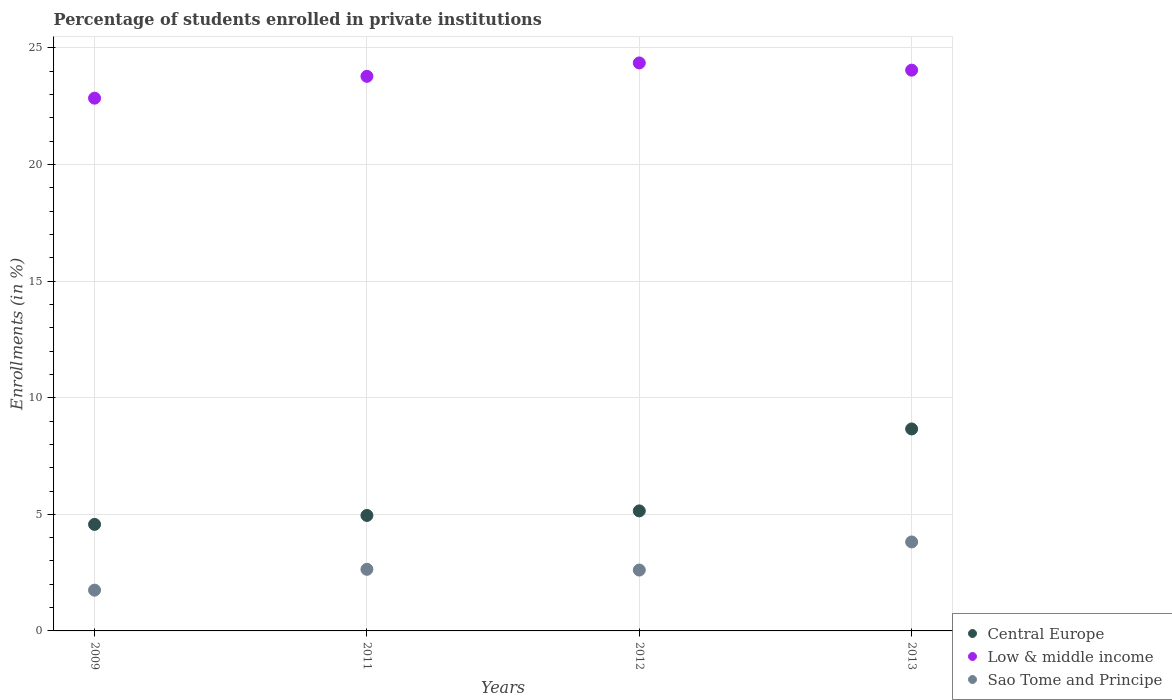How many different coloured dotlines are there?
Offer a terse response. 3. Is the number of dotlines equal to the number of legend labels?
Ensure brevity in your answer.  Yes. What is the percentage of trained teachers in Low & middle income in 2013?
Provide a short and direct response. 24.05. Across all years, what is the maximum percentage of trained teachers in Sao Tome and Principe?
Provide a succinct answer. 3.82. Across all years, what is the minimum percentage of trained teachers in Low & middle income?
Your answer should be compact. 22.85. In which year was the percentage of trained teachers in Central Europe maximum?
Offer a very short reply. 2013. What is the total percentage of trained teachers in Sao Tome and Principe in the graph?
Offer a terse response. 10.82. What is the difference between the percentage of trained teachers in Low & middle income in 2011 and that in 2013?
Provide a short and direct response. -0.26. What is the difference between the percentage of trained teachers in Central Europe in 2013 and the percentage of trained teachers in Low & middle income in 2012?
Provide a short and direct response. -15.7. What is the average percentage of trained teachers in Central Europe per year?
Offer a very short reply. 5.83. In the year 2009, what is the difference between the percentage of trained teachers in Sao Tome and Principe and percentage of trained teachers in Central Europe?
Offer a very short reply. -2.82. What is the ratio of the percentage of trained teachers in Low & middle income in 2011 to that in 2013?
Your answer should be compact. 0.99. What is the difference between the highest and the second highest percentage of trained teachers in Low & middle income?
Provide a short and direct response. 0.31. What is the difference between the highest and the lowest percentage of trained teachers in Sao Tome and Principe?
Keep it short and to the point. 2.07. In how many years, is the percentage of trained teachers in Central Europe greater than the average percentage of trained teachers in Central Europe taken over all years?
Offer a terse response. 1. Is the sum of the percentage of trained teachers in Low & middle income in 2011 and 2013 greater than the maximum percentage of trained teachers in Sao Tome and Principe across all years?
Offer a terse response. Yes. Does the percentage of trained teachers in Sao Tome and Principe monotonically increase over the years?
Your answer should be very brief. No. Is the percentage of trained teachers in Sao Tome and Principe strictly less than the percentage of trained teachers in Low & middle income over the years?
Give a very brief answer. Yes. How many dotlines are there?
Your answer should be very brief. 3. How many years are there in the graph?
Make the answer very short. 4. What is the difference between two consecutive major ticks on the Y-axis?
Your answer should be compact. 5. Are the values on the major ticks of Y-axis written in scientific E-notation?
Your answer should be compact. No. Does the graph contain any zero values?
Make the answer very short. No. How many legend labels are there?
Provide a succinct answer. 3. What is the title of the graph?
Offer a very short reply. Percentage of students enrolled in private institutions. What is the label or title of the Y-axis?
Give a very brief answer. Enrollments (in %). What is the Enrollments (in %) in Central Europe in 2009?
Offer a very short reply. 4.57. What is the Enrollments (in %) of Low & middle income in 2009?
Keep it short and to the point. 22.85. What is the Enrollments (in %) in Sao Tome and Principe in 2009?
Give a very brief answer. 1.75. What is the Enrollments (in %) of Central Europe in 2011?
Keep it short and to the point. 4.95. What is the Enrollments (in %) in Low & middle income in 2011?
Provide a succinct answer. 23.78. What is the Enrollments (in %) in Sao Tome and Principe in 2011?
Provide a short and direct response. 2.64. What is the Enrollments (in %) in Central Europe in 2012?
Offer a terse response. 5.15. What is the Enrollments (in %) of Low & middle income in 2012?
Provide a succinct answer. 24.36. What is the Enrollments (in %) in Sao Tome and Principe in 2012?
Give a very brief answer. 2.61. What is the Enrollments (in %) of Central Europe in 2013?
Make the answer very short. 8.66. What is the Enrollments (in %) in Low & middle income in 2013?
Your response must be concise. 24.05. What is the Enrollments (in %) of Sao Tome and Principe in 2013?
Provide a short and direct response. 3.82. Across all years, what is the maximum Enrollments (in %) of Central Europe?
Make the answer very short. 8.66. Across all years, what is the maximum Enrollments (in %) in Low & middle income?
Give a very brief answer. 24.36. Across all years, what is the maximum Enrollments (in %) of Sao Tome and Principe?
Your answer should be compact. 3.82. Across all years, what is the minimum Enrollments (in %) of Central Europe?
Provide a succinct answer. 4.57. Across all years, what is the minimum Enrollments (in %) of Low & middle income?
Keep it short and to the point. 22.85. Across all years, what is the minimum Enrollments (in %) of Sao Tome and Principe?
Offer a very short reply. 1.75. What is the total Enrollments (in %) in Central Europe in the graph?
Keep it short and to the point. 23.33. What is the total Enrollments (in %) in Low & middle income in the graph?
Your response must be concise. 95.03. What is the total Enrollments (in %) of Sao Tome and Principe in the graph?
Offer a terse response. 10.82. What is the difference between the Enrollments (in %) in Central Europe in 2009 and that in 2011?
Your response must be concise. -0.38. What is the difference between the Enrollments (in %) in Low & middle income in 2009 and that in 2011?
Your response must be concise. -0.94. What is the difference between the Enrollments (in %) in Sao Tome and Principe in 2009 and that in 2011?
Keep it short and to the point. -0.89. What is the difference between the Enrollments (in %) in Central Europe in 2009 and that in 2012?
Ensure brevity in your answer.  -0.58. What is the difference between the Enrollments (in %) of Low & middle income in 2009 and that in 2012?
Offer a very short reply. -1.51. What is the difference between the Enrollments (in %) in Sao Tome and Principe in 2009 and that in 2012?
Offer a very short reply. -0.86. What is the difference between the Enrollments (in %) of Central Europe in 2009 and that in 2013?
Keep it short and to the point. -4.09. What is the difference between the Enrollments (in %) in Low & middle income in 2009 and that in 2013?
Your response must be concise. -1.2. What is the difference between the Enrollments (in %) of Sao Tome and Principe in 2009 and that in 2013?
Make the answer very short. -2.07. What is the difference between the Enrollments (in %) in Central Europe in 2011 and that in 2012?
Give a very brief answer. -0.2. What is the difference between the Enrollments (in %) of Low & middle income in 2011 and that in 2012?
Give a very brief answer. -0.57. What is the difference between the Enrollments (in %) in Sao Tome and Principe in 2011 and that in 2012?
Keep it short and to the point. 0.03. What is the difference between the Enrollments (in %) of Central Europe in 2011 and that in 2013?
Offer a very short reply. -3.71. What is the difference between the Enrollments (in %) of Low & middle income in 2011 and that in 2013?
Your answer should be compact. -0.26. What is the difference between the Enrollments (in %) in Sao Tome and Principe in 2011 and that in 2013?
Provide a succinct answer. -1.17. What is the difference between the Enrollments (in %) of Central Europe in 2012 and that in 2013?
Your answer should be very brief. -3.51. What is the difference between the Enrollments (in %) in Low & middle income in 2012 and that in 2013?
Provide a succinct answer. 0.31. What is the difference between the Enrollments (in %) of Sao Tome and Principe in 2012 and that in 2013?
Offer a terse response. -1.21. What is the difference between the Enrollments (in %) of Central Europe in 2009 and the Enrollments (in %) of Low & middle income in 2011?
Provide a succinct answer. -19.21. What is the difference between the Enrollments (in %) of Central Europe in 2009 and the Enrollments (in %) of Sao Tome and Principe in 2011?
Your response must be concise. 1.93. What is the difference between the Enrollments (in %) in Low & middle income in 2009 and the Enrollments (in %) in Sao Tome and Principe in 2011?
Your answer should be compact. 20.2. What is the difference between the Enrollments (in %) of Central Europe in 2009 and the Enrollments (in %) of Low & middle income in 2012?
Give a very brief answer. -19.79. What is the difference between the Enrollments (in %) of Central Europe in 2009 and the Enrollments (in %) of Sao Tome and Principe in 2012?
Offer a very short reply. 1.96. What is the difference between the Enrollments (in %) of Low & middle income in 2009 and the Enrollments (in %) of Sao Tome and Principe in 2012?
Your response must be concise. 20.24. What is the difference between the Enrollments (in %) of Central Europe in 2009 and the Enrollments (in %) of Low & middle income in 2013?
Your response must be concise. -19.48. What is the difference between the Enrollments (in %) of Central Europe in 2009 and the Enrollments (in %) of Sao Tome and Principe in 2013?
Ensure brevity in your answer.  0.75. What is the difference between the Enrollments (in %) in Low & middle income in 2009 and the Enrollments (in %) in Sao Tome and Principe in 2013?
Offer a terse response. 19.03. What is the difference between the Enrollments (in %) of Central Europe in 2011 and the Enrollments (in %) of Low & middle income in 2012?
Provide a succinct answer. -19.4. What is the difference between the Enrollments (in %) of Central Europe in 2011 and the Enrollments (in %) of Sao Tome and Principe in 2012?
Your response must be concise. 2.34. What is the difference between the Enrollments (in %) of Low & middle income in 2011 and the Enrollments (in %) of Sao Tome and Principe in 2012?
Provide a succinct answer. 21.17. What is the difference between the Enrollments (in %) in Central Europe in 2011 and the Enrollments (in %) in Low & middle income in 2013?
Provide a short and direct response. -19.09. What is the difference between the Enrollments (in %) in Central Europe in 2011 and the Enrollments (in %) in Sao Tome and Principe in 2013?
Provide a succinct answer. 1.14. What is the difference between the Enrollments (in %) of Low & middle income in 2011 and the Enrollments (in %) of Sao Tome and Principe in 2013?
Provide a succinct answer. 19.97. What is the difference between the Enrollments (in %) in Central Europe in 2012 and the Enrollments (in %) in Low & middle income in 2013?
Provide a short and direct response. -18.9. What is the difference between the Enrollments (in %) of Central Europe in 2012 and the Enrollments (in %) of Sao Tome and Principe in 2013?
Keep it short and to the point. 1.33. What is the difference between the Enrollments (in %) in Low & middle income in 2012 and the Enrollments (in %) in Sao Tome and Principe in 2013?
Your answer should be very brief. 20.54. What is the average Enrollments (in %) in Central Europe per year?
Ensure brevity in your answer.  5.83. What is the average Enrollments (in %) of Low & middle income per year?
Keep it short and to the point. 23.76. What is the average Enrollments (in %) of Sao Tome and Principe per year?
Make the answer very short. 2.7. In the year 2009, what is the difference between the Enrollments (in %) in Central Europe and Enrollments (in %) in Low & middle income?
Provide a short and direct response. -18.28. In the year 2009, what is the difference between the Enrollments (in %) of Central Europe and Enrollments (in %) of Sao Tome and Principe?
Provide a short and direct response. 2.82. In the year 2009, what is the difference between the Enrollments (in %) in Low & middle income and Enrollments (in %) in Sao Tome and Principe?
Give a very brief answer. 21.1. In the year 2011, what is the difference between the Enrollments (in %) of Central Europe and Enrollments (in %) of Low & middle income?
Offer a terse response. -18.83. In the year 2011, what is the difference between the Enrollments (in %) of Central Europe and Enrollments (in %) of Sao Tome and Principe?
Provide a short and direct response. 2.31. In the year 2011, what is the difference between the Enrollments (in %) in Low & middle income and Enrollments (in %) in Sao Tome and Principe?
Provide a short and direct response. 21.14. In the year 2012, what is the difference between the Enrollments (in %) of Central Europe and Enrollments (in %) of Low & middle income?
Make the answer very short. -19.21. In the year 2012, what is the difference between the Enrollments (in %) of Central Europe and Enrollments (in %) of Sao Tome and Principe?
Provide a succinct answer. 2.54. In the year 2012, what is the difference between the Enrollments (in %) in Low & middle income and Enrollments (in %) in Sao Tome and Principe?
Make the answer very short. 21.75. In the year 2013, what is the difference between the Enrollments (in %) in Central Europe and Enrollments (in %) in Low & middle income?
Your response must be concise. -15.39. In the year 2013, what is the difference between the Enrollments (in %) in Central Europe and Enrollments (in %) in Sao Tome and Principe?
Offer a terse response. 4.85. In the year 2013, what is the difference between the Enrollments (in %) of Low & middle income and Enrollments (in %) of Sao Tome and Principe?
Provide a succinct answer. 20.23. What is the ratio of the Enrollments (in %) of Central Europe in 2009 to that in 2011?
Give a very brief answer. 0.92. What is the ratio of the Enrollments (in %) in Low & middle income in 2009 to that in 2011?
Your answer should be compact. 0.96. What is the ratio of the Enrollments (in %) in Sao Tome and Principe in 2009 to that in 2011?
Give a very brief answer. 0.66. What is the ratio of the Enrollments (in %) of Central Europe in 2009 to that in 2012?
Offer a terse response. 0.89. What is the ratio of the Enrollments (in %) of Low & middle income in 2009 to that in 2012?
Give a very brief answer. 0.94. What is the ratio of the Enrollments (in %) of Sao Tome and Principe in 2009 to that in 2012?
Your response must be concise. 0.67. What is the ratio of the Enrollments (in %) of Central Europe in 2009 to that in 2013?
Offer a very short reply. 0.53. What is the ratio of the Enrollments (in %) in Low & middle income in 2009 to that in 2013?
Offer a very short reply. 0.95. What is the ratio of the Enrollments (in %) of Sao Tome and Principe in 2009 to that in 2013?
Offer a terse response. 0.46. What is the ratio of the Enrollments (in %) of Low & middle income in 2011 to that in 2012?
Give a very brief answer. 0.98. What is the ratio of the Enrollments (in %) in Sao Tome and Principe in 2011 to that in 2012?
Your answer should be very brief. 1.01. What is the ratio of the Enrollments (in %) in Central Europe in 2011 to that in 2013?
Give a very brief answer. 0.57. What is the ratio of the Enrollments (in %) of Low & middle income in 2011 to that in 2013?
Ensure brevity in your answer.  0.99. What is the ratio of the Enrollments (in %) in Sao Tome and Principe in 2011 to that in 2013?
Make the answer very short. 0.69. What is the ratio of the Enrollments (in %) in Central Europe in 2012 to that in 2013?
Your answer should be compact. 0.59. What is the ratio of the Enrollments (in %) of Low & middle income in 2012 to that in 2013?
Give a very brief answer. 1.01. What is the ratio of the Enrollments (in %) in Sao Tome and Principe in 2012 to that in 2013?
Offer a very short reply. 0.68. What is the difference between the highest and the second highest Enrollments (in %) in Central Europe?
Provide a short and direct response. 3.51. What is the difference between the highest and the second highest Enrollments (in %) of Low & middle income?
Make the answer very short. 0.31. What is the difference between the highest and the second highest Enrollments (in %) in Sao Tome and Principe?
Offer a very short reply. 1.17. What is the difference between the highest and the lowest Enrollments (in %) in Central Europe?
Offer a terse response. 4.09. What is the difference between the highest and the lowest Enrollments (in %) in Low & middle income?
Provide a succinct answer. 1.51. What is the difference between the highest and the lowest Enrollments (in %) of Sao Tome and Principe?
Your answer should be very brief. 2.07. 